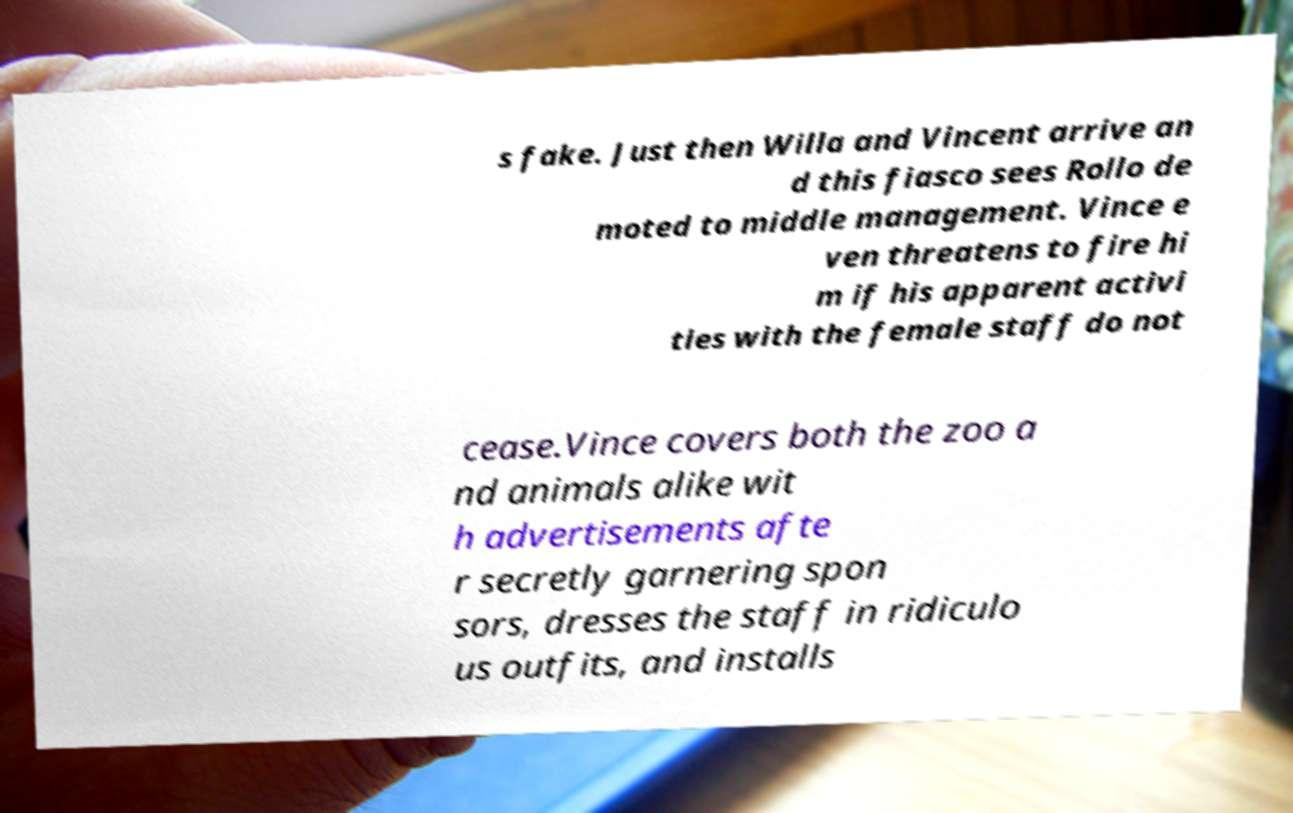Can you read and provide the text displayed in the image?This photo seems to have some interesting text. Can you extract and type it out for me? s fake. Just then Willa and Vincent arrive an d this fiasco sees Rollo de moted to middle management. Vince e ven threatens to fire hi m if his apparent activi ties with the female staff do not cease.Vince covers both the zoo a nd animals alike wit h advertisements afte r secretly garnering spon sors, dresses the staff in ridiculo us outfits, and installs 